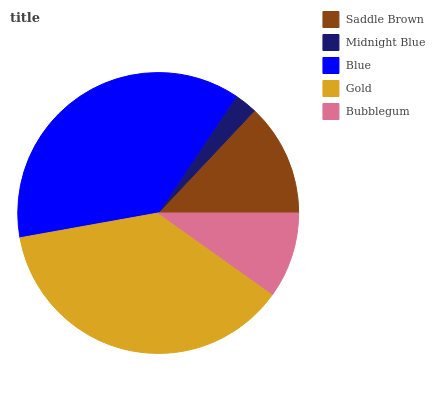Is Midnight Blue the minimum?
Answer yes or no. Yes. Is Gold the maximum?
Answer yes or no. Yes. Is Blue the minimum?
Answer yes or no. No. Is Blue the maximum?
Answer yes or no. No. Is Blue greater than Midnight Blue?
Answer yes or no. Yes. Is Midnight Blue less than Blue?
Answer yes or no. Yes. Is Midnight Blue greater than Blue?
Answer yes or no. No. Is Blue less than Midnight Blue?
Answer yes or no. No. Is Saddle Brown the high median?
Answer yes or no. Yes. Is Saddle Brown the low median?
Answer yes or no. Yes. Is Gold the high median?
Answer yes or no. No. Is Gold the low median?
Answer yes or no. No. 